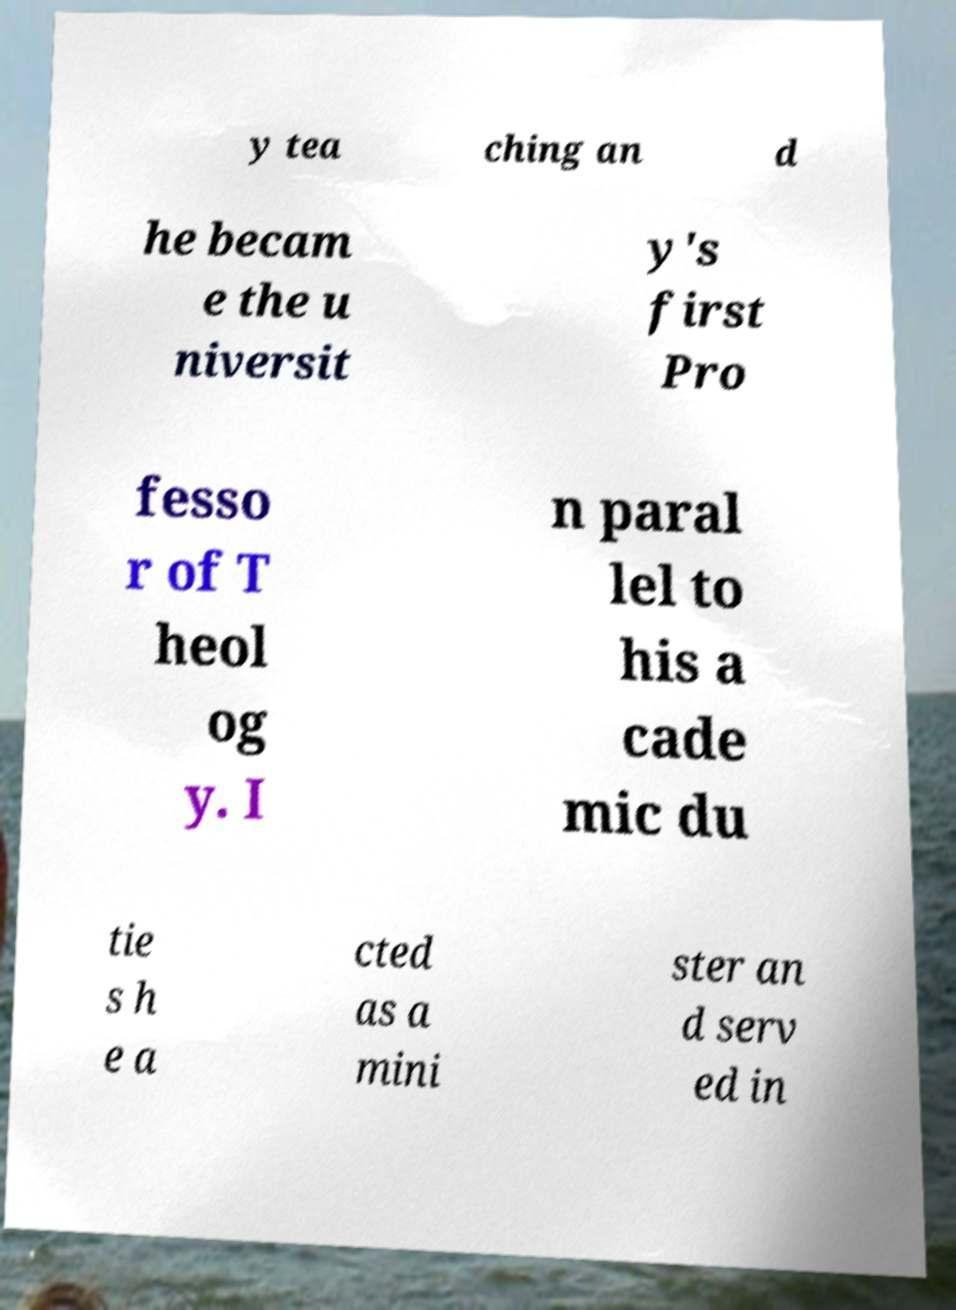Can you read and provide the text displayed in the image?This photo seems to have some interesting text. Can you extract and type it out for me? y tea ching an d he becam e the u niversit y's first Pro fesso r of T heol og y. I n paral lel to his a cade mic du tie s h e a cted as a mini ster an d serv ed in 